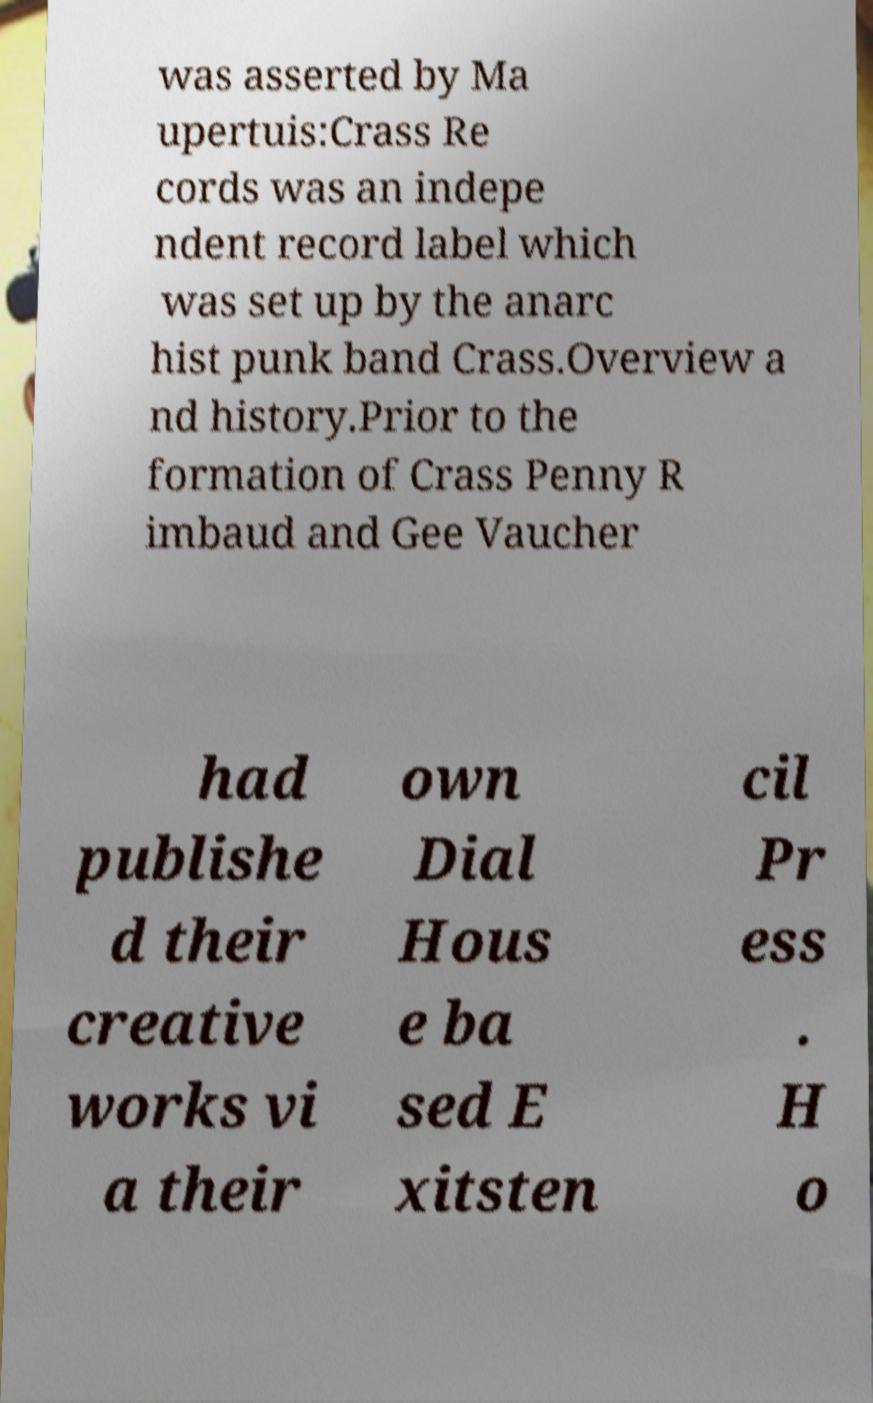What messages or text are displayed in this image? I need them in a readable, typed format. was asserted by Ma upertuis:Crass Re cords was an indepe ndent record label which was set up by the anarc hist punk band Crass.Overview a nd history.Prior to the formation of Crass Penny R imbaud and Gee Vaucher had publishe d their creative works vi a their own Dial Hous e ba sed E xitsten cil Pr ess . H o 